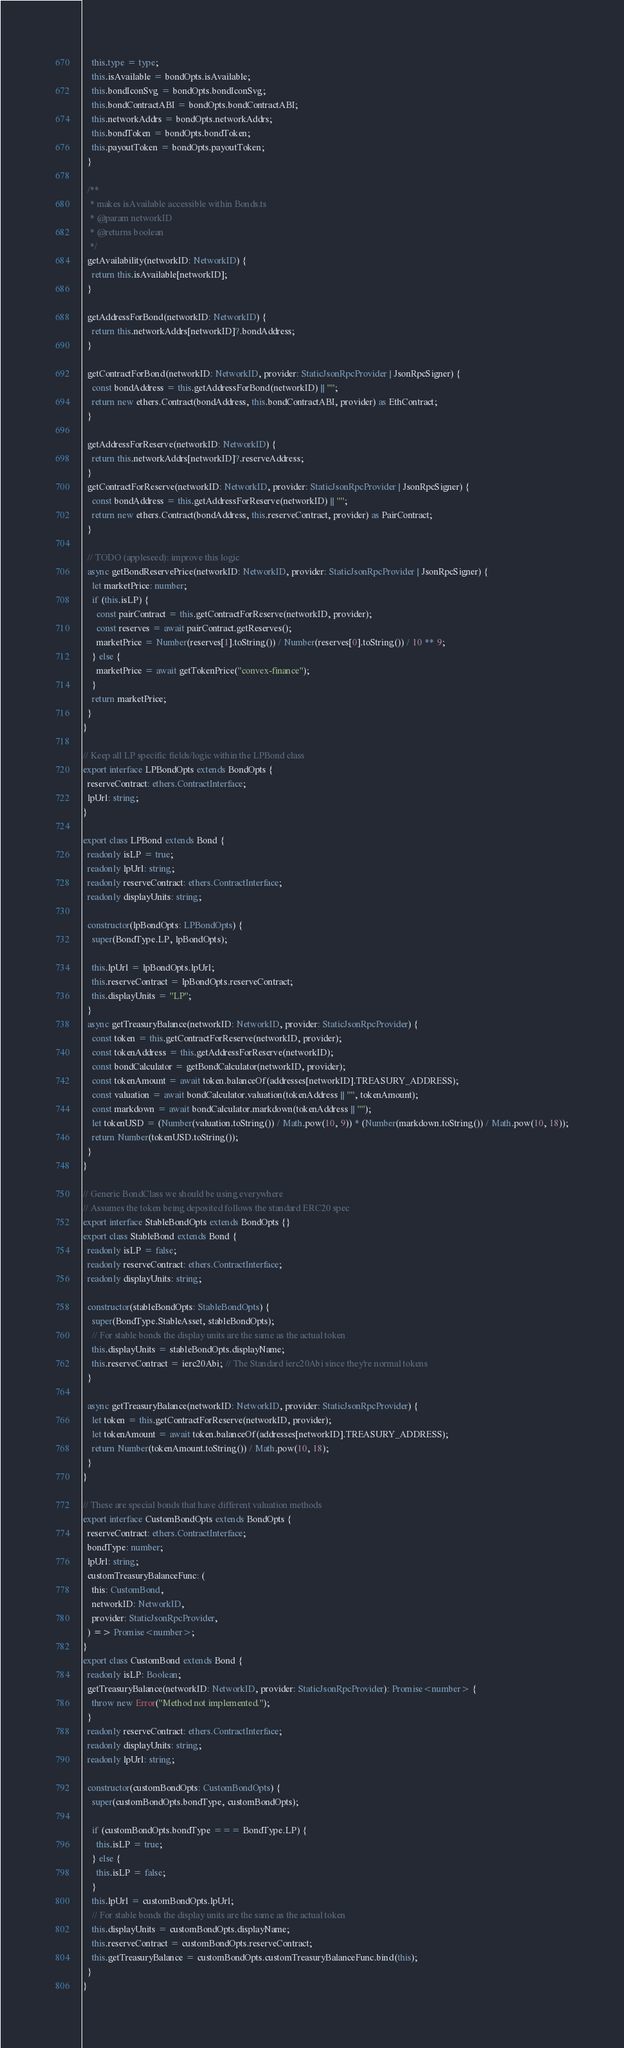Convert code to text. <code><loc_0><loc_0><loc_500><loc_500><_TypeScript_>    this.type = type;
    this.isAvailable = bondOpts.isAvailable;
    this.bondIconSvg = bondOpts.bondIconSvg;
    this.bondContractABI = bondOpts.bondContractABI;
    this.networkAddrs = bondOpts.networkAddrs;
    this.bondToken = bondOpts.bondToken;
    this.payoutToken = bondOpts.payoutToken;
  }

  /**
   * makes isAvailable accessible within Bonds.ts
   * @param networkID
   * @returns boolean
   */
  getAvailability(networkID: NetworkID) {
    return this.isAvailable[networkID];
  }

  getAddressForBond(networkID: NetworkID) {
    return this.networkAddrs[networkID]?.bondAddress;
  }

  getContractForBond(networkID: NetworkID, provider: StaticJsonRpcProvider | JsonRpcSigner) {
    const bondAddress = this.getAddressForBond(networkID) || "";
    return new ethers.Contract(bondAddress, this.bondContractABI, provider) as EthContract;
  }

  getAddressForReserve(networkID: NetworkID) {
    return this.networkAddrs[networkID]?.reserveAddress;
  }
  getContractForReserve(networkID: NetworkID, provider: StaticJsonRpcProvider | JsonRpcSigner) {
    const bondAddress = this.getAddressForReserve(networkID) || "";
    return new ethers.Contract(bondAddress, this.reserveContract, provider) as PairContract;
  }

  // TODO (appleseed): improve this logic
  async getBondReservePrice(networkID: NetworkID, provider: StaticJsonRpcProvider | JsonRpcSigner) {
    let marketPrice: number;
    if (this.isLP) {
      const pairContract = this.getContractForReserve(networkID, provider);
      const reserves = await pairContract.getReserves();
      marketPrice = Number(reserves[1].toString()) / Number(reserves[0].toString()) / 10 ** 9;
    } else {
      marketPrice = await getTokenPrice("convex-finance");
    }
    return marketPrice;
  }
}

// Keep all LP specific fields/logic within the LPBond class
export interface LPBondOpts extends BondOpts {
  reserveContract: ethers.ContractInterface;
  lpUrl: string;
}

export class LPBond extends Bond {
  readonly isLP = true;
  readonly lpUrl: string;
  readonly reserveContract: ethers.ContractInterface;
  readonly displayUnits: string;

  constructor(lpBondOpts: LPBondOpts) {
    super(BondType.LP, lpBondOpts);

    this.lpUrl = lpBondOpts.lpUrl;
    this.reserveContract = lpBondOpts.reserveContract;
    this.displayUnits = "LP";
  }
  async getTreasuryBalance(networkID: NetworkID, provider: StaticJsonRpcProvider) {
    const token = this.getContractForReserve(networkID, provider);
    const tokenAddress = this.getAddressForReserve(networkID);
    const bondCalculator = getBondCalculator(networkID, provider);
    const tokenAmount = await token.balanceOf(addresses[networkID].TREASURY_ADDRESS);
    const valuation = await bondCalculator.valuation(tokenAddress || "", tokenAmount);
    const markdown = await bondCalculator.markdown(tokenAddress || "");
    let tokenUSD = (Number(valuation.toString()) / Math.pow(10, 9)) * (Number(markdown.toString()) / Math.pow(10, 18));
    return Number(tokenUSD.toString());
  }
}

// Generic BondClass we should be using everywhere
// Assumes the token being deposited follows the standard ERC20 spec
export interface StableBondOpts extends BondOpts {}
export class StableBond extends Bond {
  readonly isLP = false;
  readonly reserveContract: ethers.ContractInterface;
  readonly displayUnits: string;

  constructor(stableBondOpts: StableBondOpts) {
    super(BondType.StableAsset, stableBondOpts);
    // For stable bonds the display units are the same as the actual token
    this.displayUnits = stableBondOpts.displayName;
    this.reserveContract = ierc20Abi; // The Standard ierc20Abi since they're normal tokens
  }

  async getTreasuryBalance(networkID: NetworkID, provider: StaticJsonRpcProvider) {
    let token = this.getContractForReserve(networkID, provider);
    let tokenAmount = await token.balanceOf(addresses[networkID].TREASURY_ADDRESS);
    return Number(tokenAmount.toString()) / Math.pow(10, 18);
  }
}

// These are special bonds that have different valuation methods
export interface CustomBondOpts extends BondOpts {
  reserveContract: ethers.ContractInterface;
  bondType: number;
  lpUrl: string;
  customTreasuryBalanceFunc: (
    this: CustomBond,
    networkID: NetworkID,
    provider: StaticJsonRpcProvider,
  ) => Promise<number>;
}
export class CustomBond extends Bond {
  readonly isLP: Boolean;
  getTreasuryBalance(networkID: NetworkID, provider: StaticJsonRpcProvider): Promise<number> {
    throw new Error("Method not implemented.");
  }
  readonly reserveContract: ethers.ContractInterface;
  readonly displayUnits: string;
  readonly lpUrl: string;

  constructor(customBondOpts: CustomBondOpts) {
    super(customBondOpts.bondType, customBondOpts);

    if (customBondOpts.bondType === BondType.LP) {
      this.isLP = true;
    } else {
      this.isLP = false;
    }
    this.lpUrl = customBondOpts.lpUrl;
    // For stable bonds the display units are the same as the actual token
    this.displayUnits = customBondOpts.displayName;
    this.reserveContract = customBondOpts.reserveContract;
    this.getTreasuryBalance = customBondOpts.customTreasuryBalanceFunc.bind(this);
  }
}
</code> 